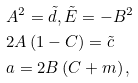<formula> <loc_0><loc_0><loc_500><loc_500>& A ^ { 2 } = \tilde { d } , \tilde { E } = - B ^ { 2 } \\ & 2 A \left ( 1 - C \right ) = \tilde { c } \\ & a = 2 B \left ( C + m \right ) ,</formula> 